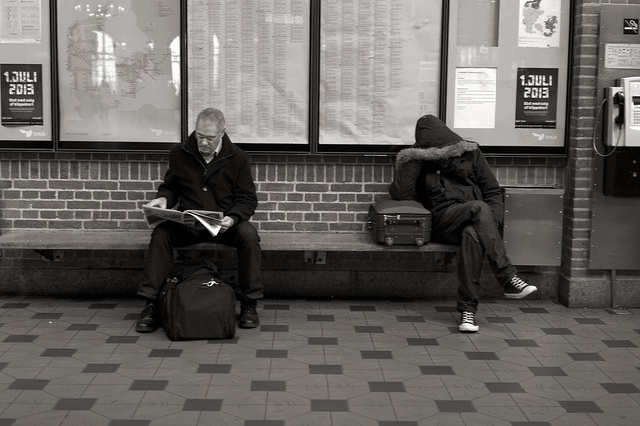Describe the objects in this image and their specific colors. I can see people in lightgray, black, gray, and darkgray tones, people in lightgray, black, gray, and darkgray tones, bench in lightgray, black, and gray tones, backpack in lightgray, black, gray, and darkgray tones, and handbag in lightgray, black, gray, darkgray, and white tones in this image. 